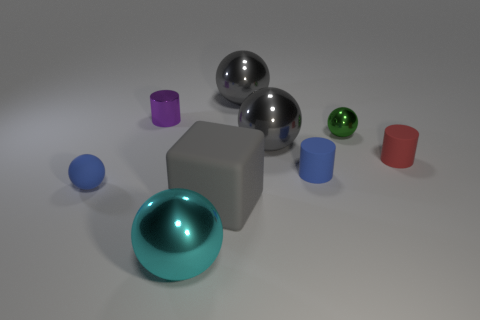There is a small blue rubber thing that is on the right side of the blue ball; are there any small purple cylinders to the right of it? Upon examining the image, there are no small purple cylinders located to the right of the small blue object near the blue ball. The objects present are mainly spherical or cubic, dominated by a mix of cool tones such as blues and a contrast of warmer tones like the solitary red cylinder. 